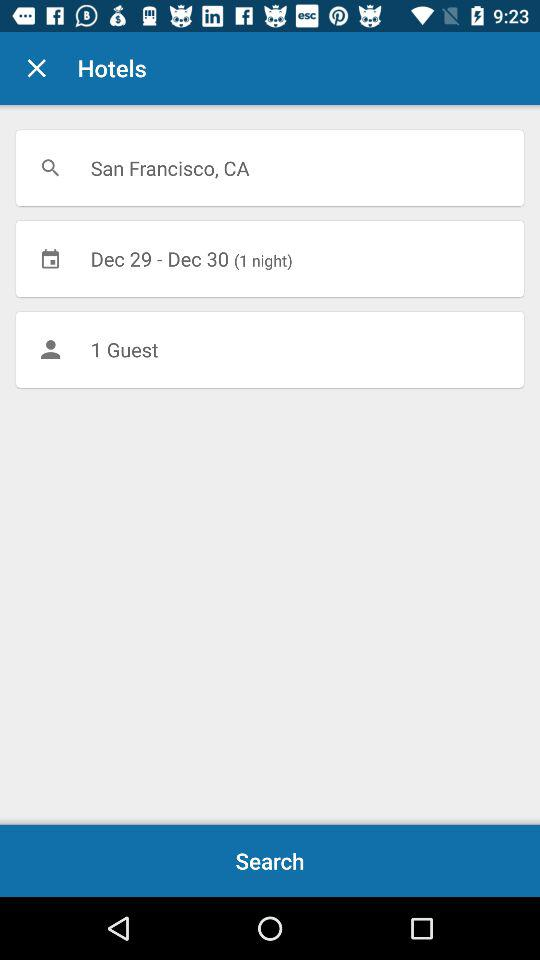How many days are the user searching for?
Answer the question using a single word or phrase. 1 